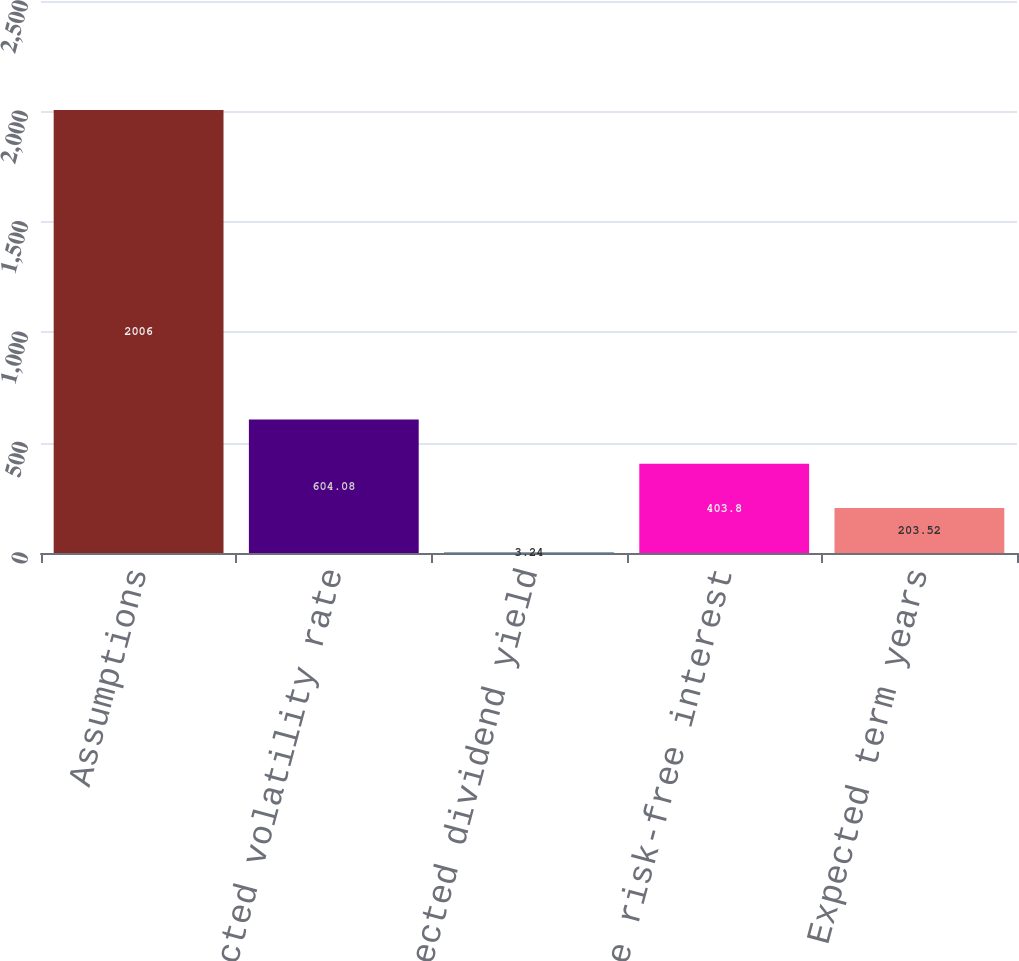Convert chart to OTSL. <chart><loc_0><loc_0><loc_500><loc_500><bar_chart><fcel>Assumptions<fcel>Expected volatility rate<fcel>Expected dividend yield<fcel>Average risk-free interest<fcel>Expected term years<nl><fcel>2006<fcel>604.08<fcel>3.24<fcel>403.8<fcel>203.52<nl></chart> 